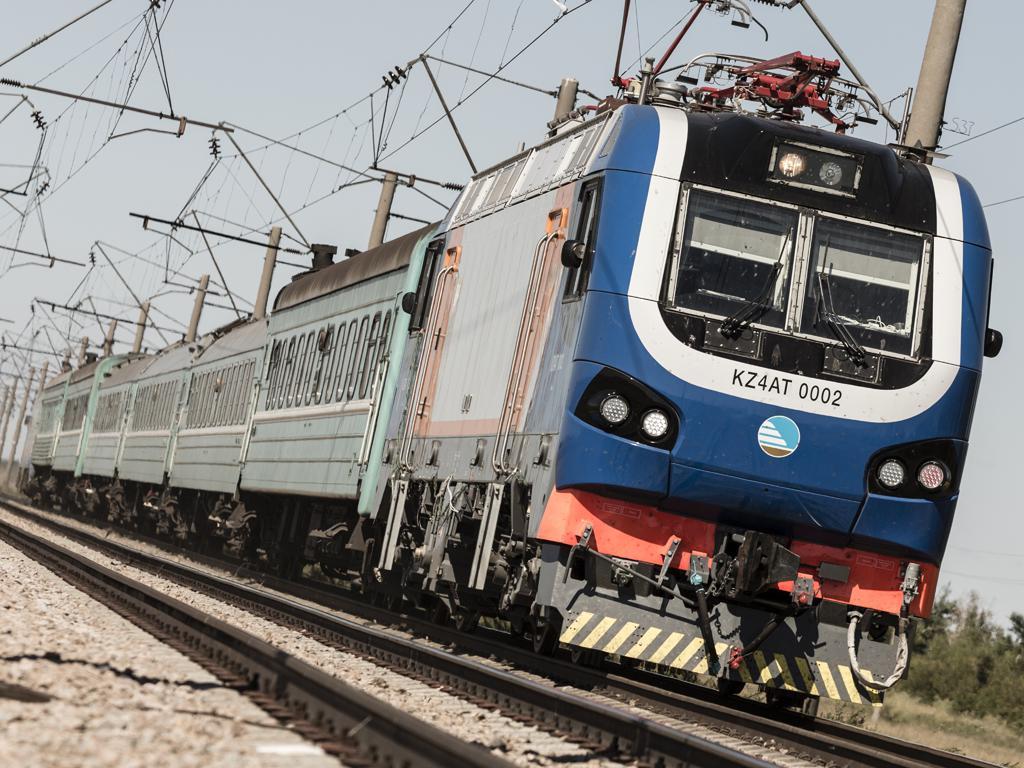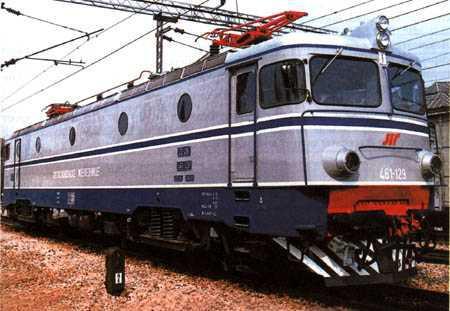The first image is the image on the left, the second image is the image on the right. For the images shown, is this caption "One image shows a red and white train angled to face leftward." true? Answer yes or no. No. The first image is the image on the left, the second image is the image on the right. Evaluate the accuracy of this statement regarding the images: "the train in the image on the left does not have any round windows". Is it true? Answer yes or no. Yes. 